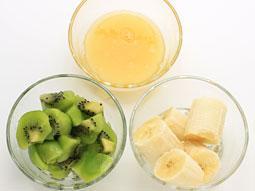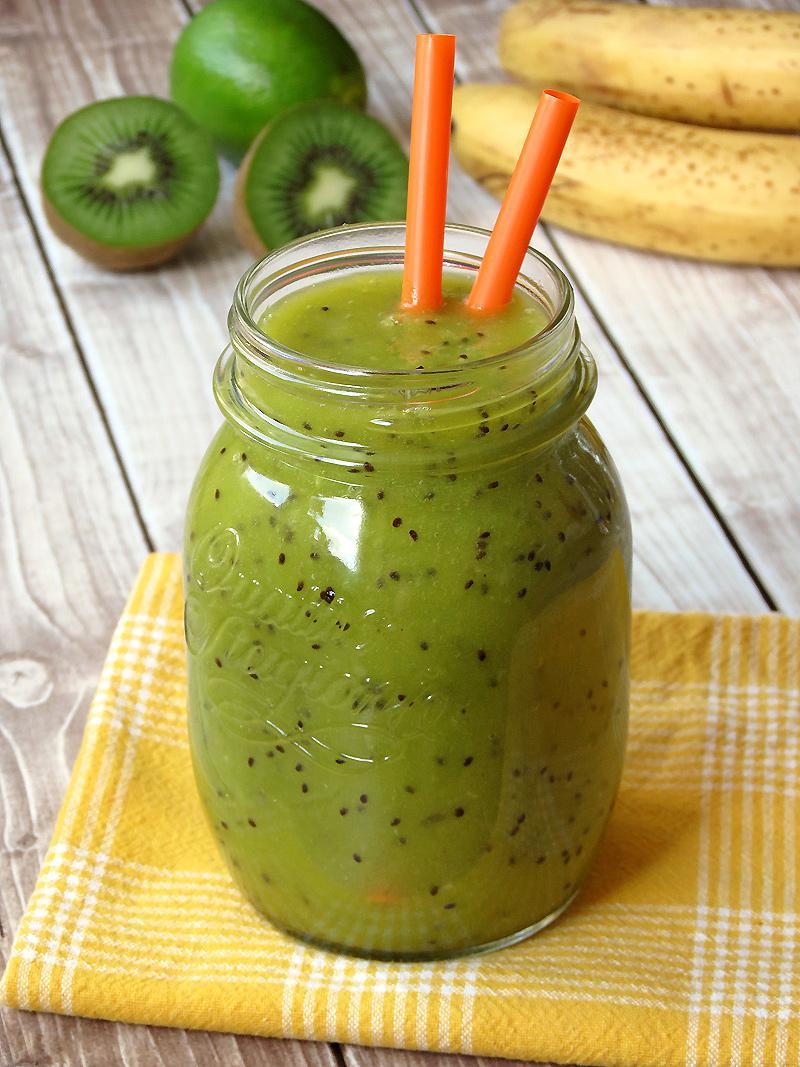The first image is the image on the left, the second image is the image on the right. Assess this claim about the two images: "One image shows chopped kiwi fruit, banana chunks, and lemon juice, while the second image includes a prepared green smoothie and cut kiwi fruit.". Correct or not? Answer yes or no. Yes. The first image is the image on the left, the second image is the image on the right. For the images shown, is this caption "A glass containing a speckled green beverage is garnished with a kiwi fruit slice." true? Answer yes or no. No. 